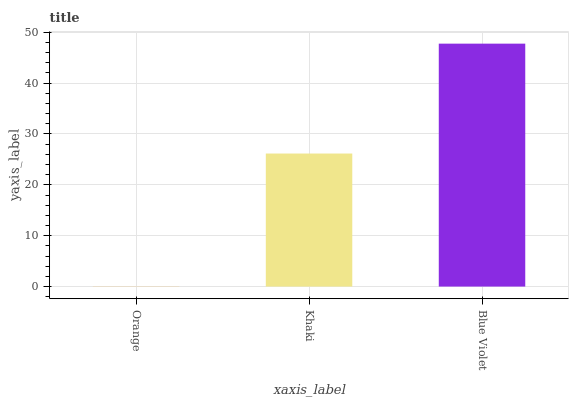Is Orange the minimum?
Answer yes or no. Yes. Is Blue Violet the maximum?
Answer yes or no. Yes. Is Khaki the minimum?
Answer yes or no. No. Is Khaki the maximum?
Answer yes or no. No. Is Khaki greater than Orange?
Answer yes or no. Yes. Is Orange less than Khaki?
Answer yes or no. Yes. Is Orange greater than Khaki?
Answer yes or no. No. Is Khaki less than Orange?
Answer yes or no. No. Is Khaki the high median?
Answer yes or no. Yes. Is Khaki the low median?
Answer yes or no. Yes. Is Orange the high median?
Answer yes or no. No. Is Orange the low median?
Answer yes or no. No. 